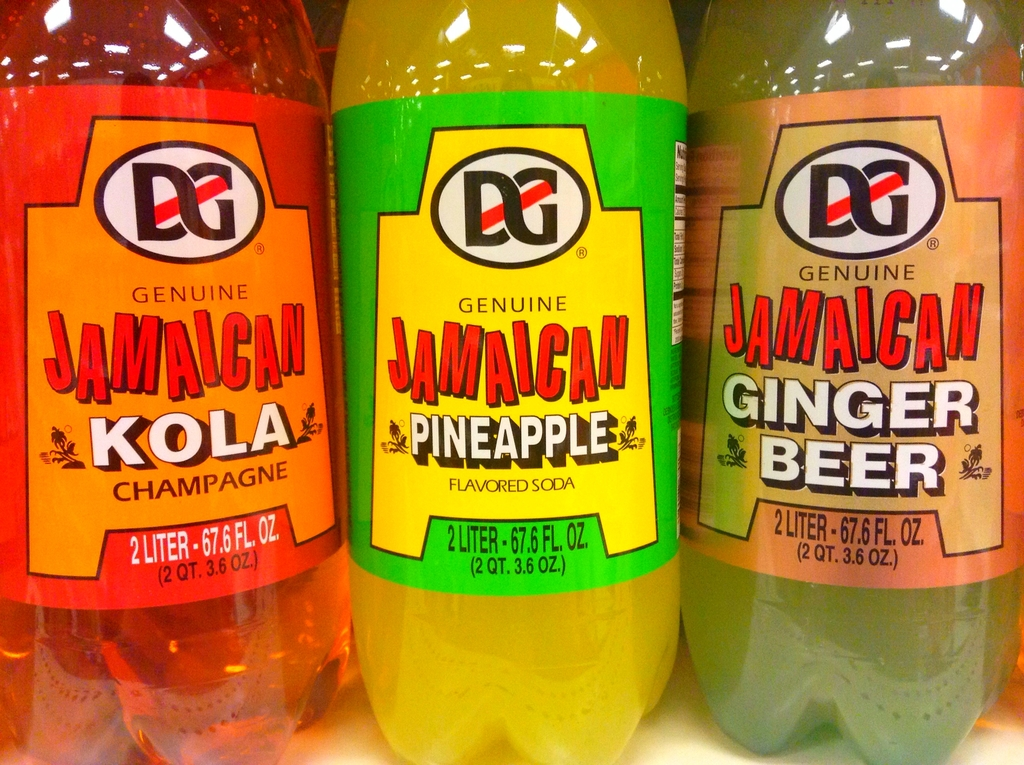Could these drinks be used in any interesting culinary ways? Yes, these sodas can be creatively incorporated into culinary recipes. For instance, Ginger Beer could be used to add a spicy twist to marinades, the Kola Champagne makes a unique addition to dessert reductions, and the Pineapple soda could brighten up a tropical cocktail or be used as a base for a summery sorbet. 